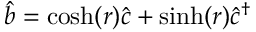Convert formula to latex. <formula><loc_0><loc_0><loc_500><loc_500>\hat { b } = \cosh ( r ) \hat { c } + \sinh ( r ) \hat { c } ^ { \dagger }</formula> 